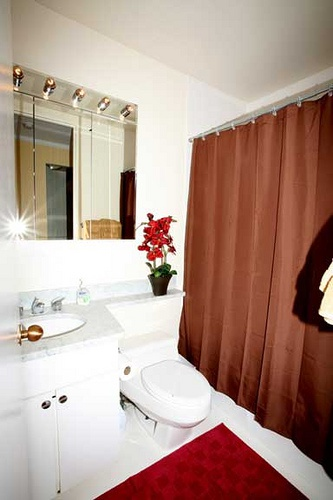Describe the objects in this image and their specific colors. I can see toilet in gray, white, darkgray, and lightgray tones, potted plant in gray, black, brown, maroon, and ivory tones, sink in gray, white, darkgray, and lightgray tones, and vase in gray, black, and darkgreen tones in this image. 